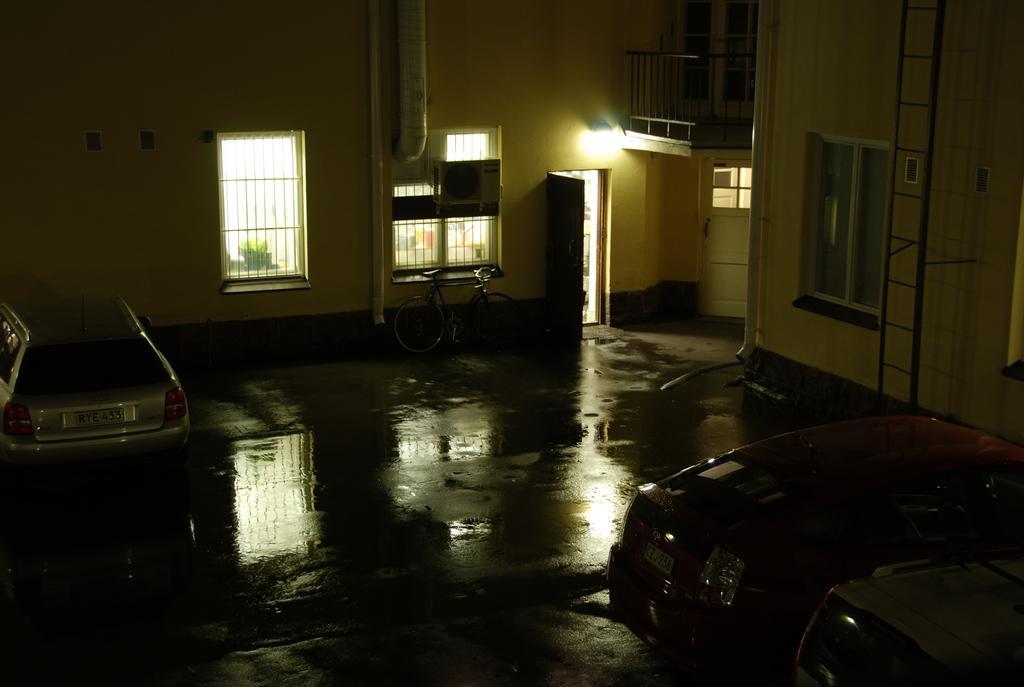In one or two sentences, can you explain what this image depicts? In this image on the right side and left side there are cars, in the center there is cycle, windows, door, light, pipe, air cooler and ladder and railing. At the bottom there is floor, and on the floor there is some water and through the windows we could see some plants. 